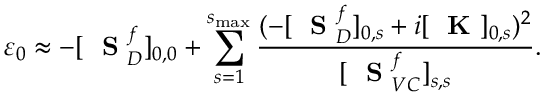<formula> <loc_0><loc_0><loc_500><loc_500>\varepsilon _ { 0 } \approx - [ S _ { D } ^ { f } ] _ { 0 , 0 } + \sum _ { s = 1 } ^ { s _ { \max } } \frac { ( - [ S _ { D } ^ { f } ] _ { 0 , s } + i [ K ] _ { 0 , s } ) ^ { 2 } } { [ S _ { V C } ^ { f } ] _ { s , s } } .</formula> 